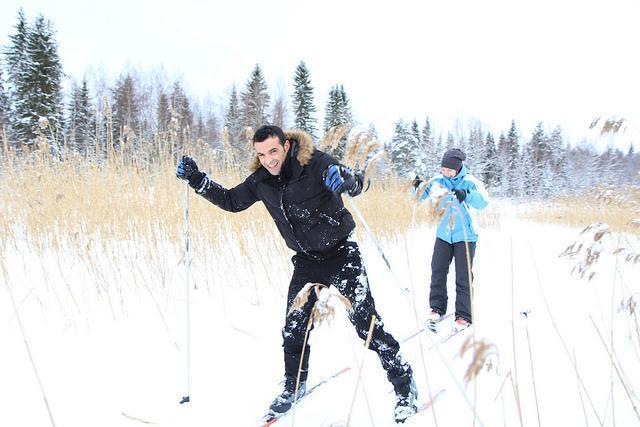How many women are in this picture?
Give a very brief answer. 1. How many people can you see?
Give a very brief answer. 2. How many people are wearing orange jackets?
Give a very brief answer. 0. 